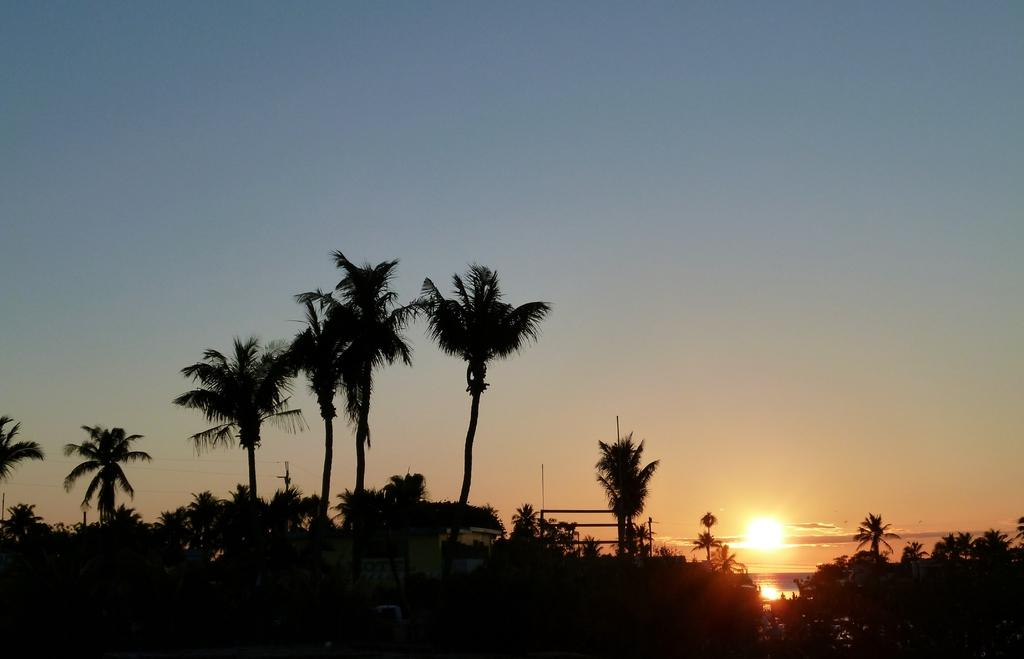What type of vegetation can be seen in the image? There are trees in the image. What structures are present in the image? There are houses and poles in the image. What else can be seen in the image besides the trees and structures? There are wires in the image. What is visible in the sky in the image? The sky is visible in the image, and there are clouds and the sun visible. What type of drum can be seen in the image? There is no drum present in the image. What is the view from the coast in the image? There is no coast present in the image, so it is not possible to describe a view from the coast. 